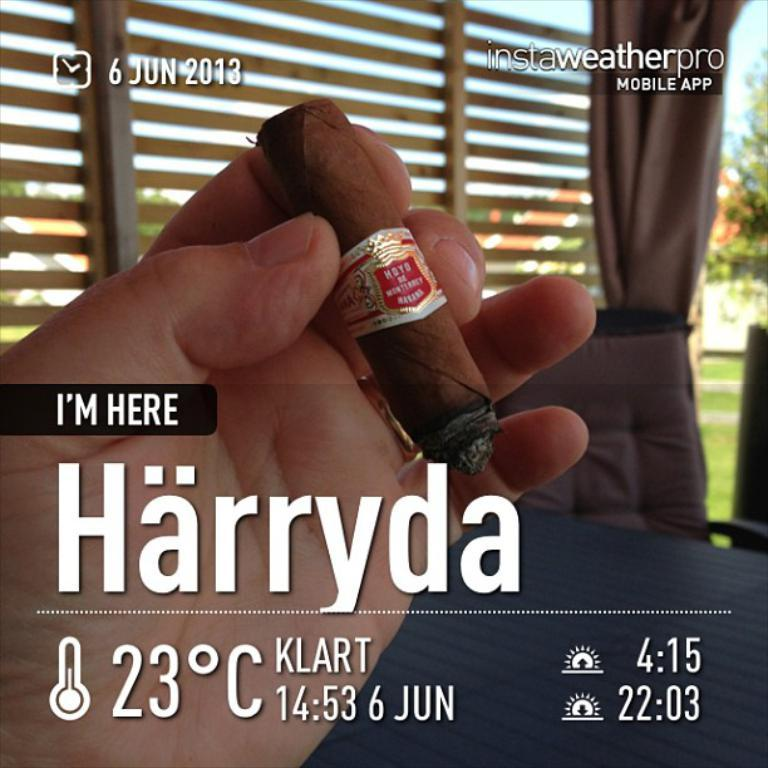What is the person in the image holding? There is a hand holding a cigarette in the image. What can be seen in the background of the image? There is a chair, a curtain, grass, a wall, trees, and the sky visible in the background of the image. How many mice are swimming in the grass in the image? There are no mice present in the image, and they are not swimming in the grass. 